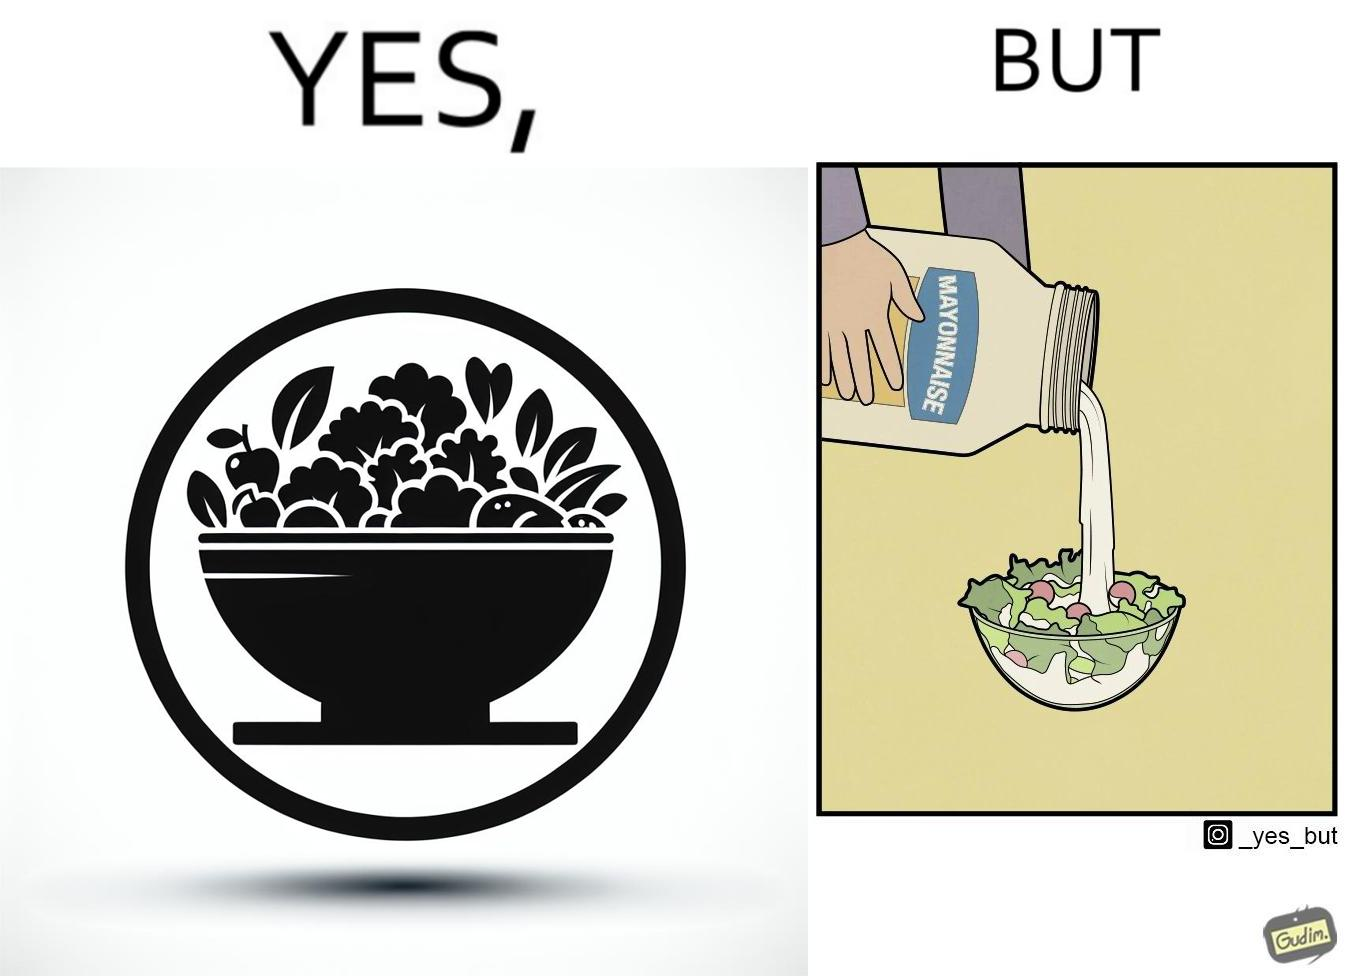What is shown in the left half versus the right half of this image? In the left part of the image: salad in a bowl In the right part of the image: pouring mayonnaise sauce on salad in a bowl 